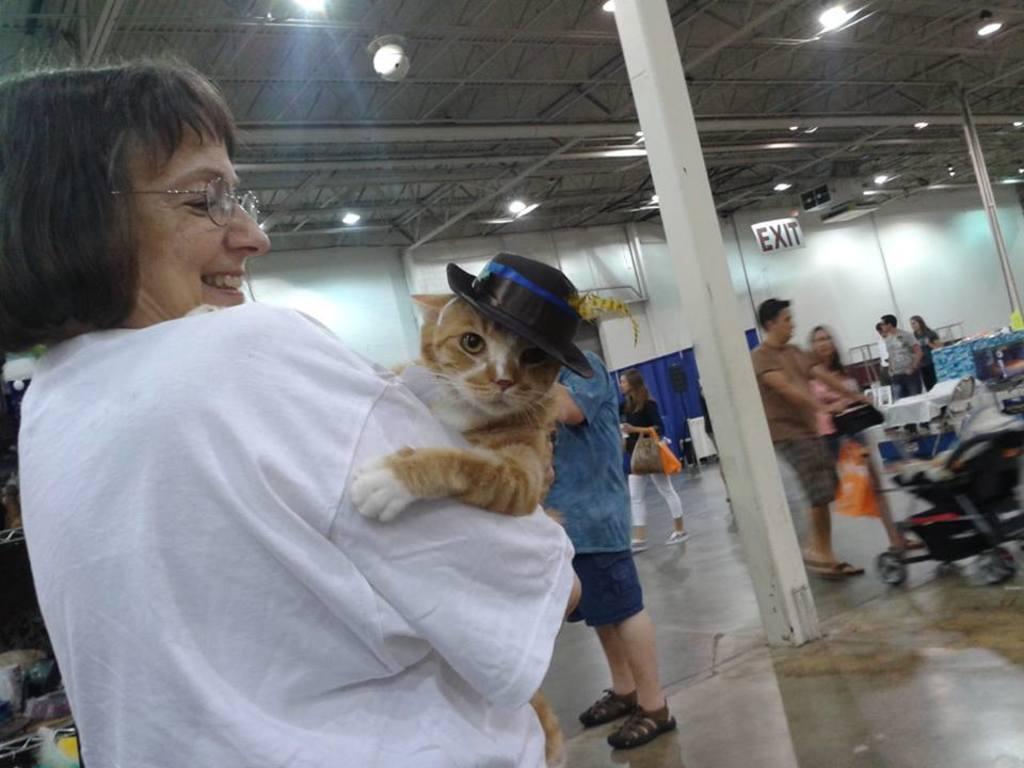In one or two sentences, can you explain what this image depicts? This image consists of a woman holding a cat. She is wearing a white T-shirt. In this image, there are many persons. It looks like an airport. At the bottom, there is a floor. In the front, there is a pillar. At the top, there is a roof along with lights. On the right, we can see a man holding a trolley. 